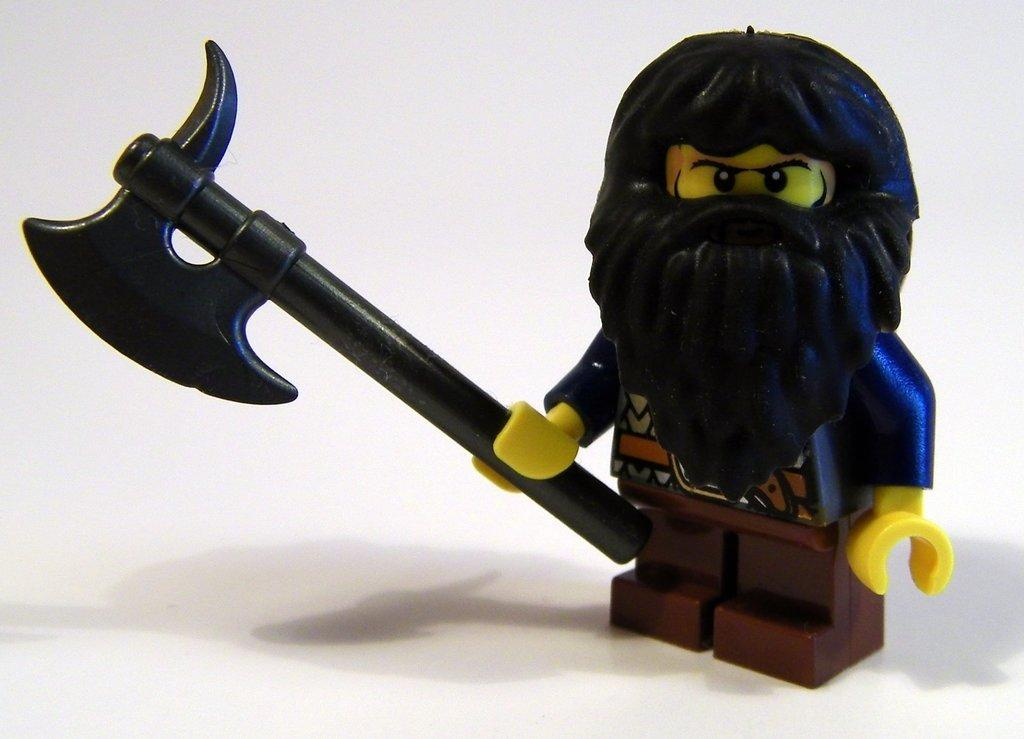What is the main subject of the image? There is a doll in the image. Where is the doll located? The doll is on the floor. What other object can be seen in the image? There is a toy axe in the image. What is the color of the toy axe? The toy axe is black in color. What type of shame can be seen on the doll's face in the image? There is no indication of shame on the doll's face in the image. 